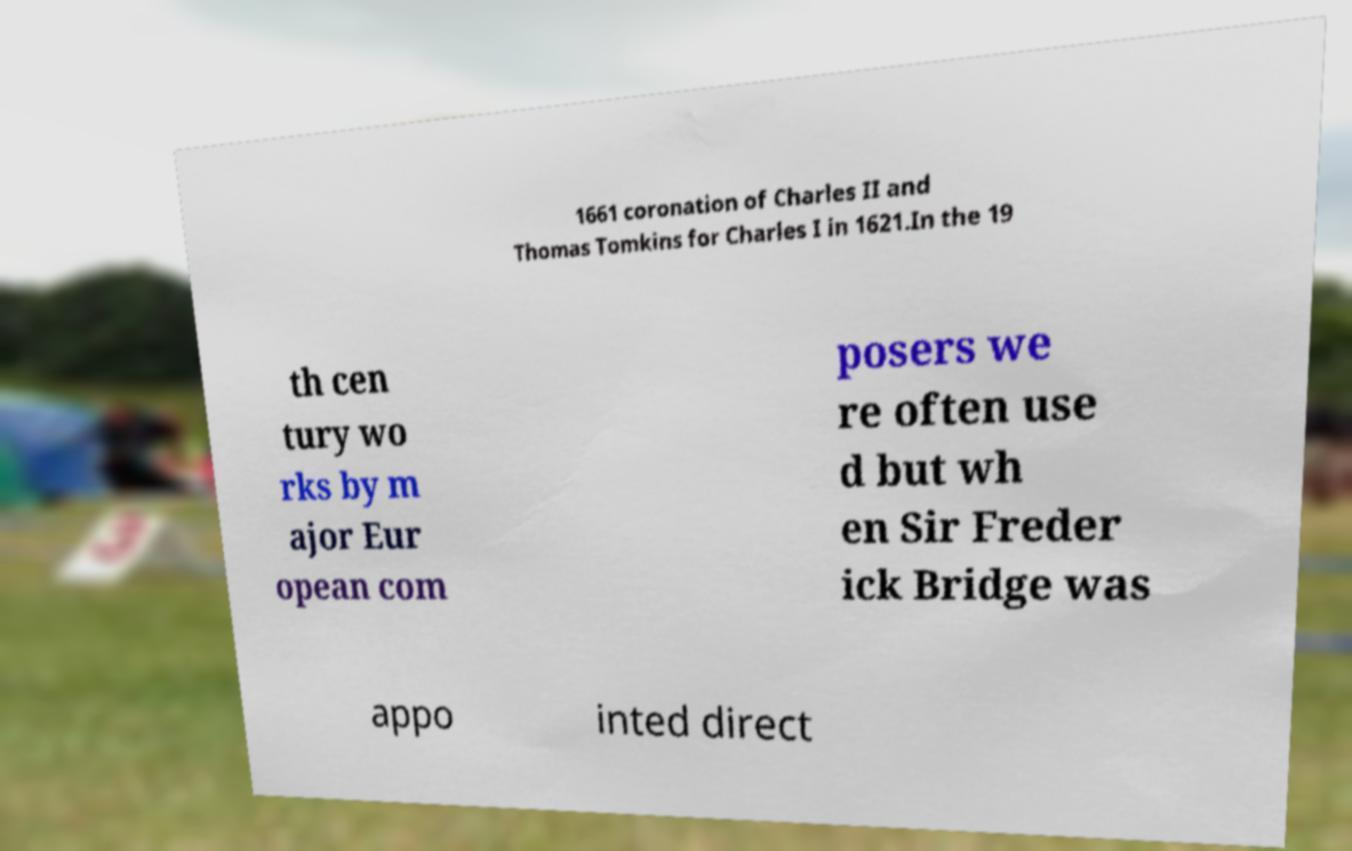Can you read and provide the text displayed in the image?This photo seems to have some interesting text. Can you extract and type it out for me? 1661 coronation of Charles II and Thomas Tomkins for Charles I in 1621.In the 19 th cen tury wo rks by m ajor Eur opean com posers we re often use d but wh en Sir Freder ick Bridge was appo inted direct 